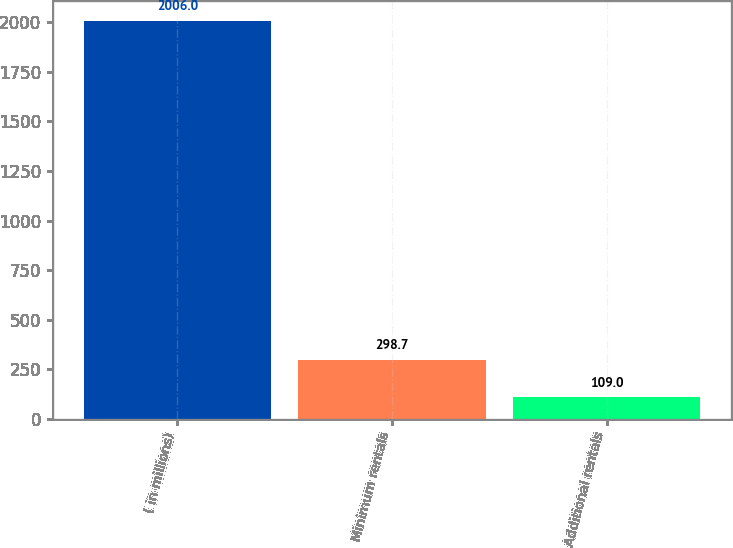Convert chart to OTSL. <chart><loc_0><loc_0><loc_500><loc_500><bar_chart><fcel>( in millions)<fcel>Minimum rentals<fcel>Additional rentals<nl><fcel>2006<fcel>298.7<fcel>109<nl></chart> 